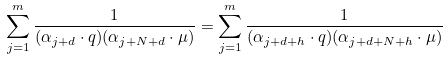Convert formula to latex. <formula><loc_0><loc_0><loc_500><loc_500>\sum _ { j = 1 } ^ { m } \frac { 1 } { ( \alpha _ { j + d } \cdot q ) ( \alpha _ { j + N + d } \cdot \mu ) } = \sum _ { j = 1 } ^ { m } \frac { 1 } { ( \alpha _ { j + d + h } \cdot q ) ( \alpha _ { j + d + N + h } \cdot \mu ) }</formula> 